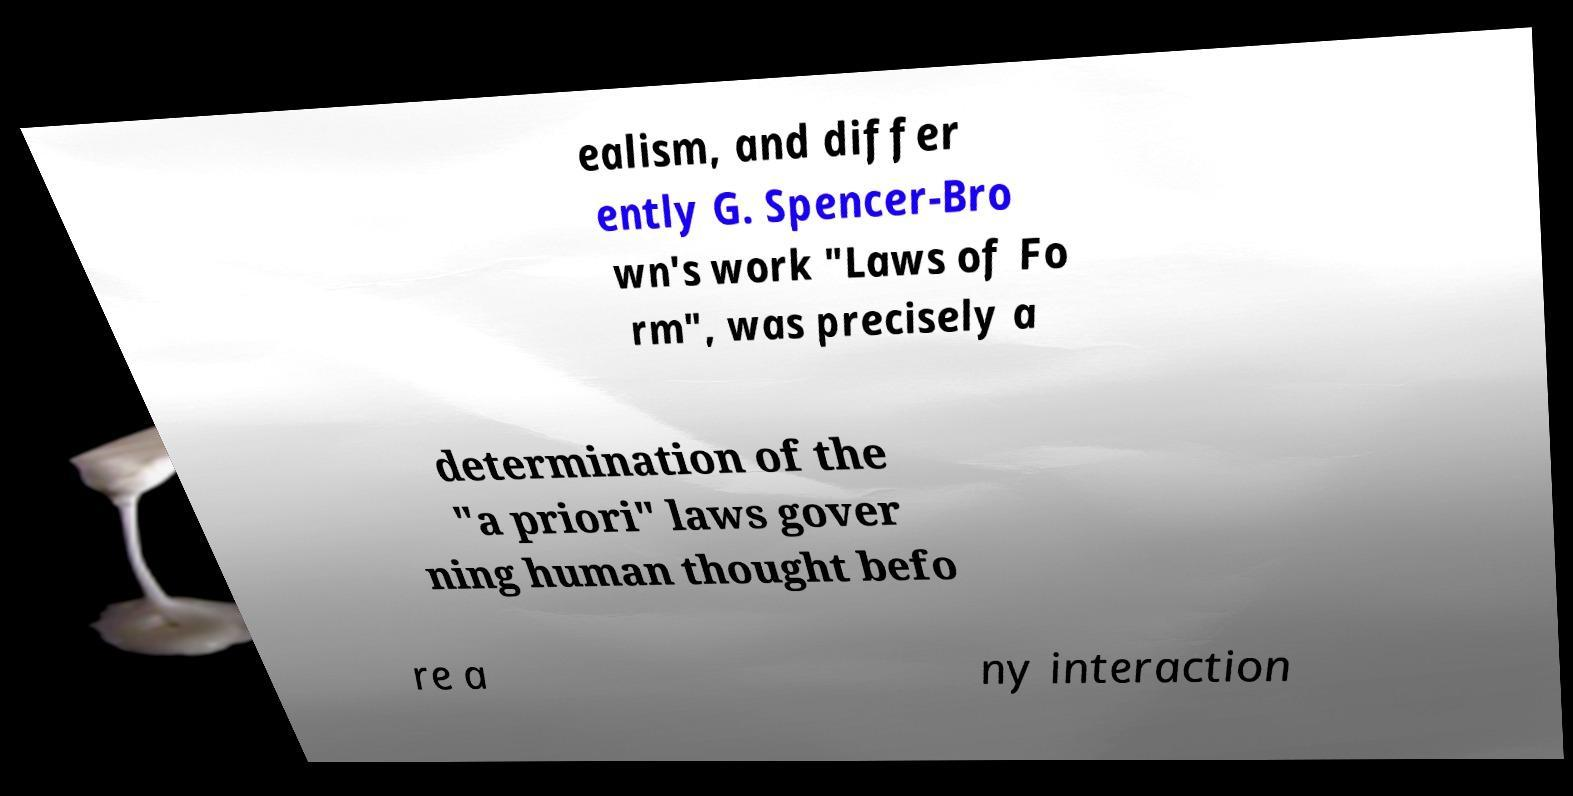Can you read and provide the text displayed in the image?This photo seems to have some interesting text. Can you extract and type it out for me? ealism, and differ ently G. Spencer-Bro wn's work "Laws of Fo rm", was precisely a determination of the "a priori" laws gover ning human thought befo re a ny interaction 